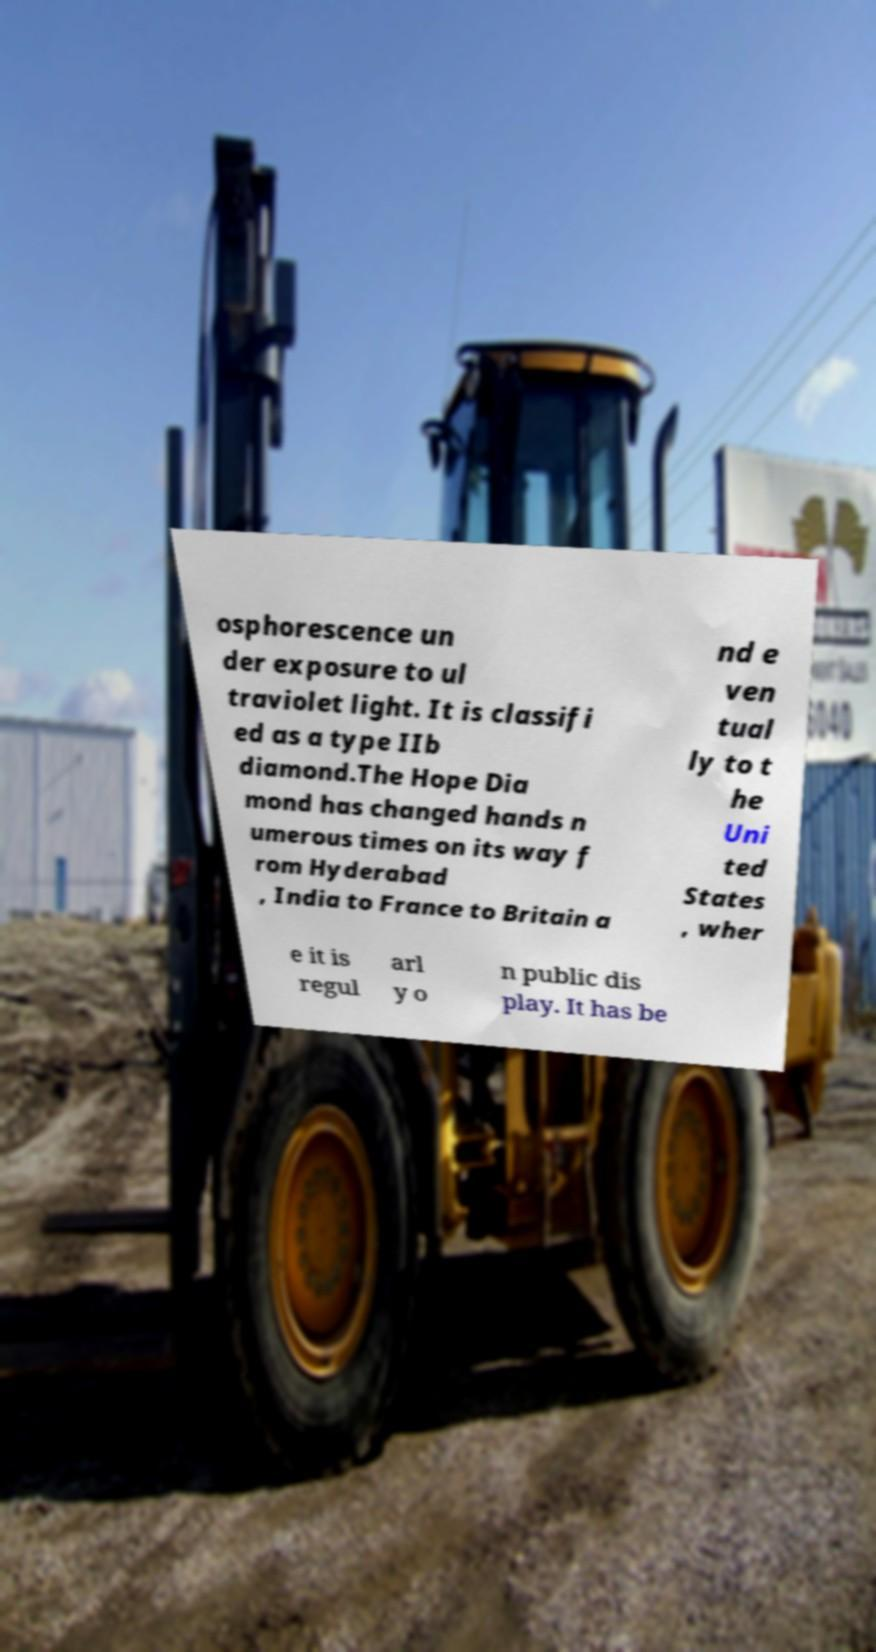Could you assist in decoding the text presented in this image and type it out clearly? osphorescence un der exposure to ul traviolet light. It is classifi ed as a type IIb diamond.The Hope Dia mond has changed hands n umerous times on its way f rom Hyderabad , India to France to Britain a nd e ven tual ly to t he Uni ted States , wher e it is regul arl y o n public dis play. It has be 